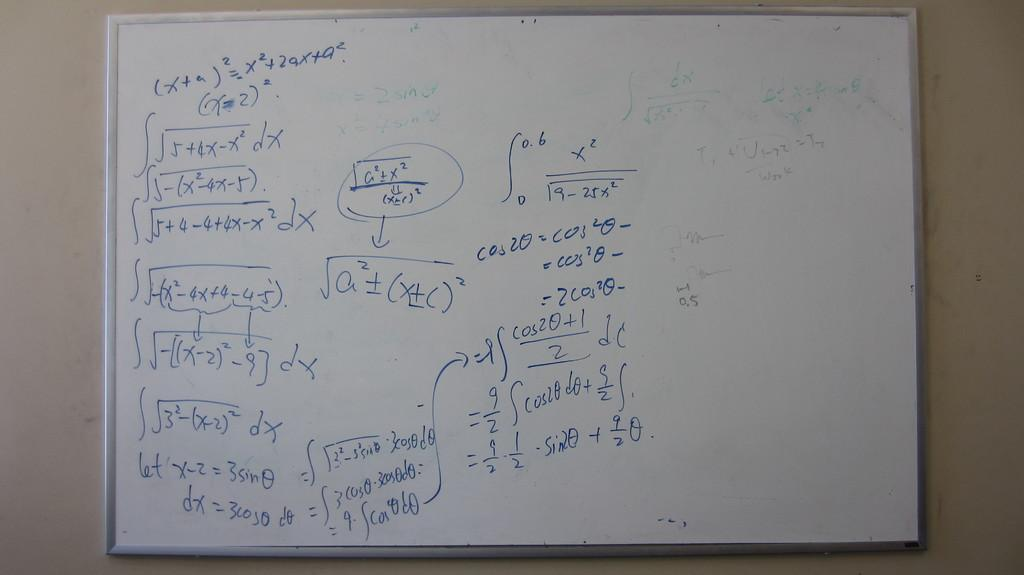<image>
Render a clear and concise summary of the photo. Math equations involving sin and cos are scribbled on a board 